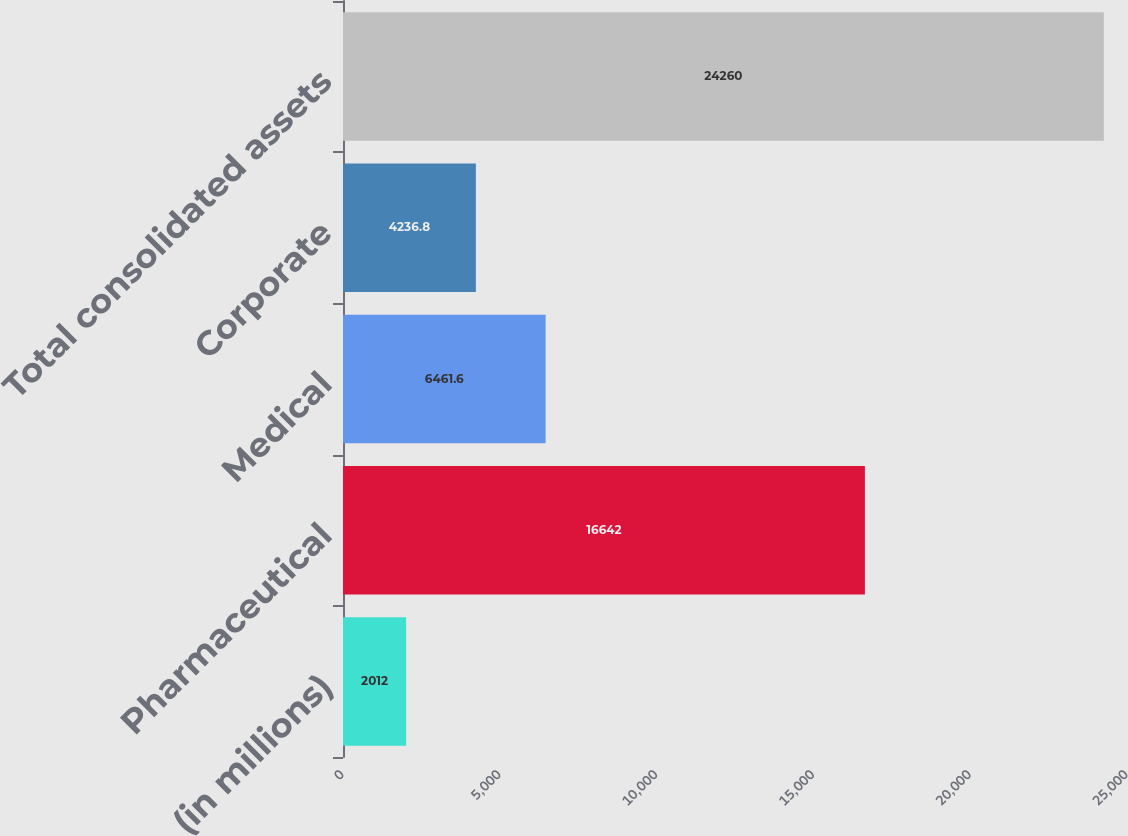Convert chart. <chart><loc_0><loc_0><loc_500><loc_500><bar_chart><fcel>(in millions)<fcel>Pharmaceutical<fcel>Medical<fcel>Corporate<fcel>Total consolidated assets<nl><fcel>2012<fcel>16642<fcel>6461.6<fcel>4236.8<fcel>24260<nl></chart> 